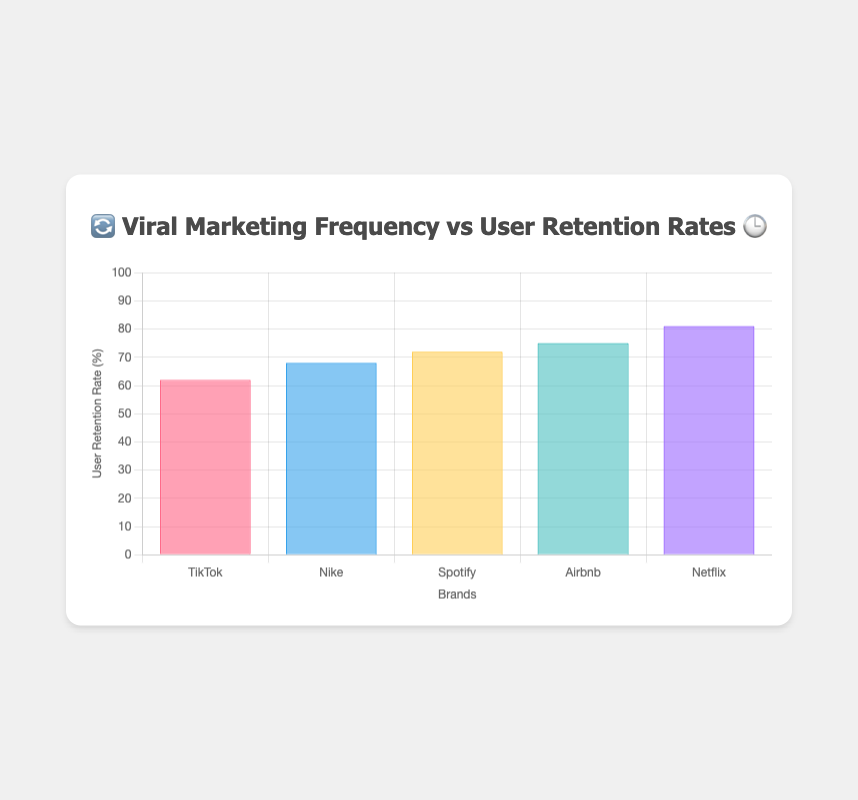What is the title of the chart? The chart's title is displayed at the top center and usually summarizes the main focus of the plot. The title reads "🔄 Viral Marketing Frequency vs User Retention Rates 🕒."
Answer: 🔄 Viral Marketing Frequency vs User Retention Rates 🕒 Which brand has the highest user retention rate? By examining the bar heights, we see that Netflix has the tallest bar representing the highest percentage. The tooltip also reveals a retention rate of 81%.
Answer: Netflix What viral marketing frequency is used by TikTok? The tooltip shows that TikTok has a user retention rate of 62%. The tooltip further specifies the frequency as "Daily 📅."
Answer: Daily 📅 What is the user retention rate for Spotify? Hovering over Spotify's bar reveals a user retention rate of 72%.
Answer: 72% Which brand has a lower retention rate, Nike or TikTok? Comparing the bar heights, TikTok has a retention rate of 62%, while Nike has 68%. Since 62% is lower than 68%, TikTok has the lower retention rate.
Answer: TikTok How does the retention rate of Airbnb compare to that of Nike? Comparing the bars for Airbnb and Nike, Airbnb has a retention rate of 75% and Nike has 68%. So, Airbnb has a higher retention rate.
Answer: Airbnb has a higher retention rate What is the average user retention rate for all the brands shown? Add all the retention rates (68% + 72% + 75% + 81% + 62%) and divide by the number of brands (5): (68 + 72 + 75 + 81 + 62) / 5 = 71.6%.
Answer: 71.6% Which marketing frequency is associated with the highest user retention rate? By considering the highest retention rate (Netflix, 81%) and checking the tooltip or labels, we find that the frequency is "Quarterly 🗓️."
Answer: Quarterly 🗓️ Which brand uses a Bi-weekly 🗓️ frequency, and what is their user retention rate? By referring to the tooltips, we see that Spotify uses the Bi-weekly 🗓️ frequency, with a retention rate of 72%.
Answer: Spotify, 72% How many brands are shown in the chart? Counting the unique labels on the x-axis, we identify five brands: Nike, Spotify, Airbnb, Netflix, and TikTok.
Answer: 5 What is the difference in retention rate between the brand with the highest and lowest rates? The highest retention rate is 81% (Netflix) and the lowest is 62% (TikTok). The difference is 81 - 62 = 19%.
Answer: 19% 